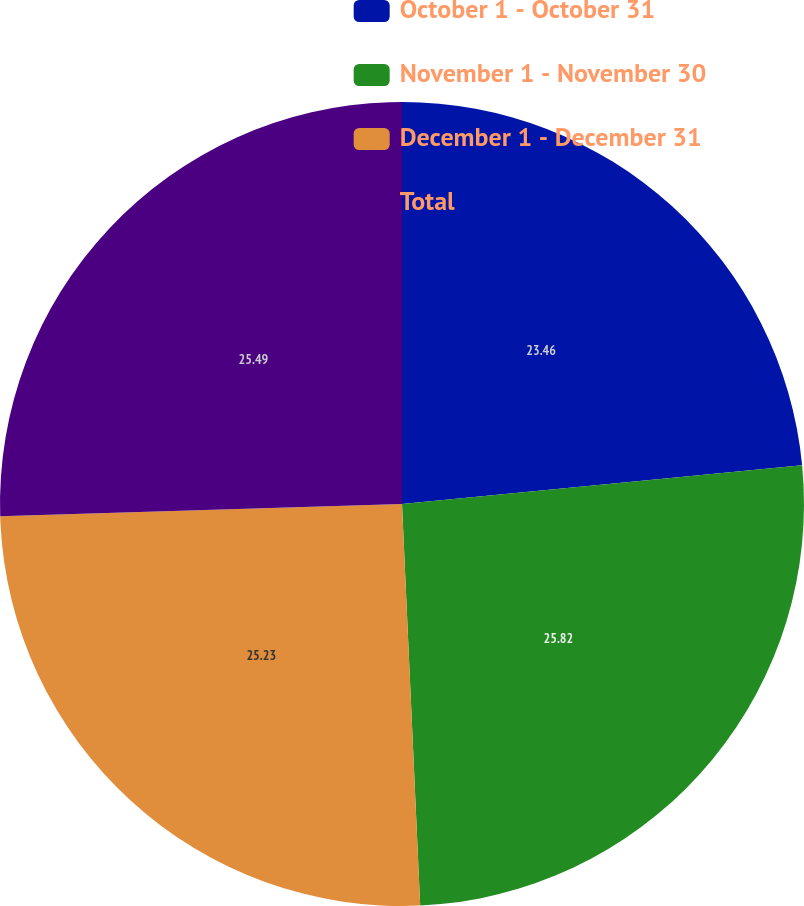Convert chart to OTSL. <chart><loc_0><loc_0><loc_500><loc_500><pie_chart><fcel>October 1 - October 31<fcel>November 1 - November 30<fcel>December 1 - December 31<fcel>Total<nl><fcel>23.46%<fcel>25.82%<fcel>25.23%<fcel>25.49%<nl></chart> 